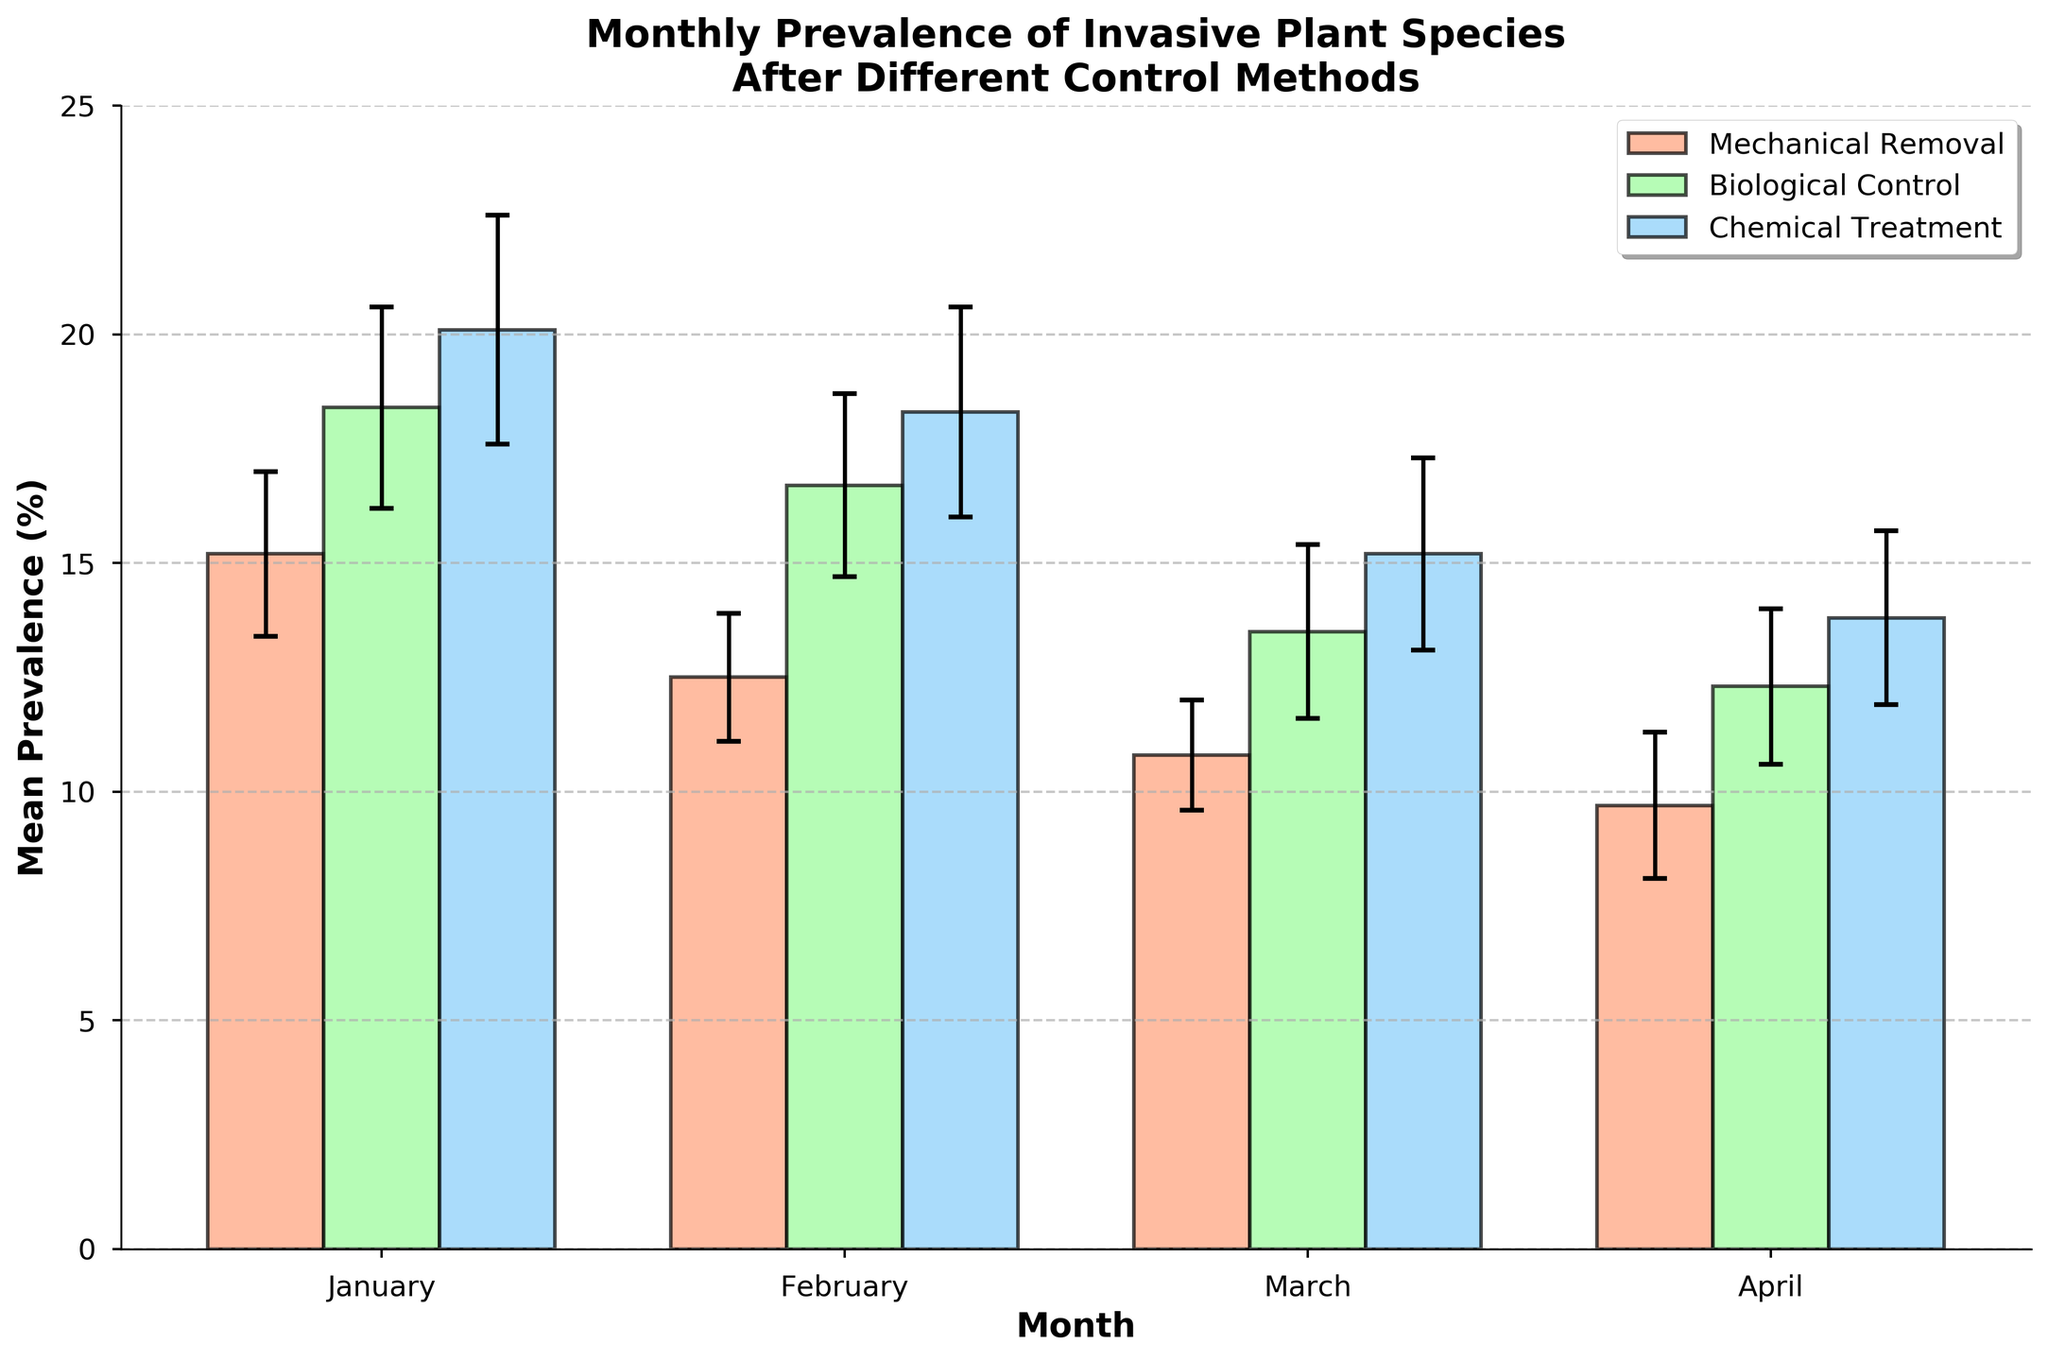What is the title of the figure? The title of the figure is located at the top center and describes the subject of the visualization.
Answer: Monthly Prevalence of Invasive Plant Species After Different Control Methods Which control method shows the highest mean prevalence in January? By looking at the heights of the bars for January, you can see that the bar representing "Chemical Treatment" is the tallest.
Answer: Chemical Treatment Which month has the lowest mean prevalence for each control method? Review the bar heights for each method across all months. For Mechanical Removal, April has the lowest bar. For Biological Control, April also has the lowest bar. For Chemical Treatment, April again has the lowest bar.
Answer: April What is the difference in mean prevalence between Mechanical Removal and Biological Control in February? Find the heights of the bars for Mechanical Removal and Biological Control in February. Subtract the mean prevalence of Mechanical Removal (12.5) from Biological Control (16.7).
Answer: 4.2 Which month shows the largest reduction in mean prevalence for Mechanical Removal compared to the previous month? Calculate the differences between consecutive months for Mechanical Removal: Jan-Feb (15.2 - 12.5 = 2.7), Feb-Mar (12.5 - 10.8 = 1.7), Mar-Apr (10.8 - 9.7 = 1.1). The largest reduction is from January to February.
Answer: January to February What is the overall trend of the mean prevalence for Chemical Treatment over the months? Look at the series of bars for Chemical Treatment from January to April. The heights of the bars consistently decrease.
Answer: Decreasing Compare the error bars of Mechanical Removal and Biological Control in March. Which method has larger variability? Look at the lengths of the error bars for both methods in March. The error bar for Biological Control (1.9) is longer than that for Mechanical Removal (1.2).
Answer: Biological Control What is the average mean prevalence in April across all control methods? Sum the mean prevalences of April for all methods (9.7 for Mechanical Removal, 12.3 for Biological Control, and 13.8 for Chemical Treatment). Divide by 3. \( (9.7 + 12.3 + 13.8) / 3 = 11.93 \)
Answer: 11.93 Which control method shows the smallest error bar in January? Examine the error bars for each method in January. The error bar for Mechanical Removal is the shortest (1.8).
Answer: Mechanical Removal 